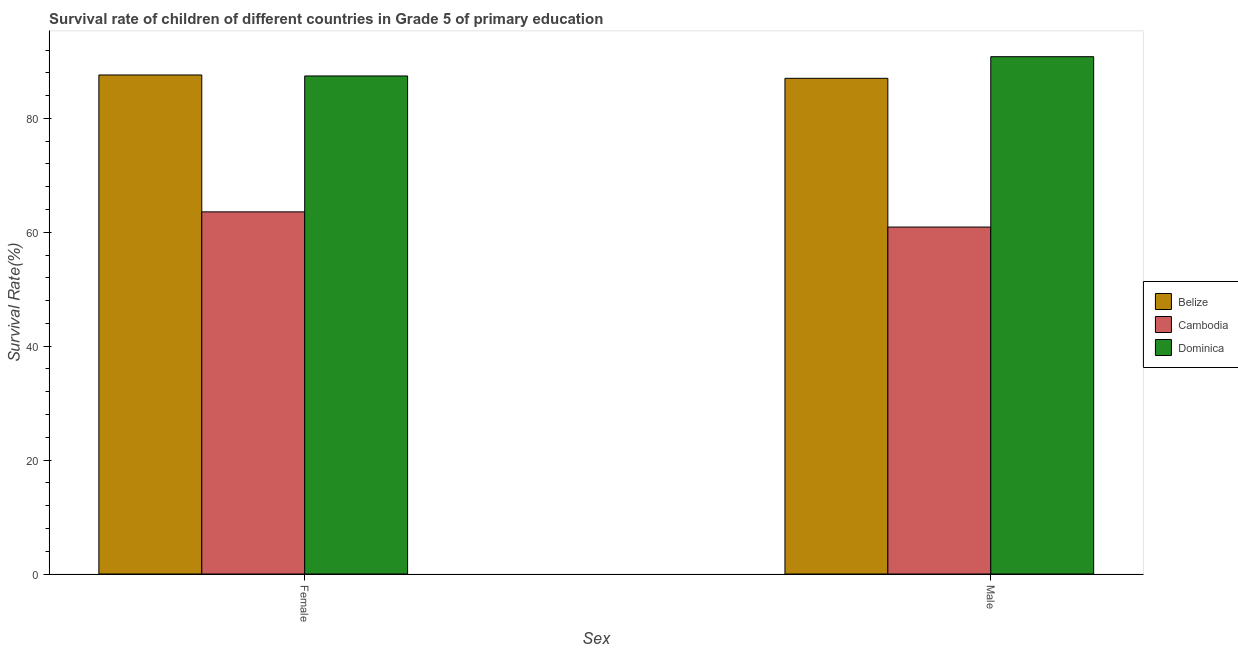Are the number of bars on each tick of the X-axis equal?
Provide a short and direct response. Yes. How many bars are there on the 2nd tick from the left?
Give a very brief answer. 3. How many bars are there on the 1st tick from the right?
Ensure brevity in your answer.  3. What is the label of the 2nd group of bars from the left?
Your answer should be very brief. Male. What is the survival rate of male students in primary education in Cambodia?
Give a very brief answer. 60.92. Across all countries, what is the maximum survival rate of female students in primary education?
Provide a succinct answer. 87.63. Across all countries, what is the minimum survival rate of male students in primary education?
Provide a succinct answer. 60.92. In which country was the survival rate of female students in primary education maximum?
Provide a short and direct response. Belize. In which country was the survival rate of female students in primary education minimum?
Keep it short and to the point. Cambodia. What is the total survival rate of female students in primary education in the graph?
Your response must be concise. 238.67. What is the difference between the survival rate of female students in primary education in Dominica and that in Cambodia?
Ensure brevity in your answer.  23.87. What is the difference between the survival rate of male students in primary education in Cambodia and the survival rate of female students in primary education in Dominica?
Ensure brevity in your answer.  -26.54. What is the average survival rate of female students in primary education per country?
Offer a terse response. 79.56. What is the difference between the survival rate of female students in primary education and survival rate of male students in primary education in Dominica?
Keep it short and to the point. -3.38. In how many countries, is the survival rate of male students in primary education greater than 52 %?
Your response must be concise. 3. What is the ratio of the survival rate of female students in primary education in Cambodia to that in Dominica?
Your answer should be compact. 0.73. Is the survival rate of female students in primary education in Dominica less than that in Cambodia?
Your answer should be compact. No. What does the 3rd bar from the left in Male represents?
Provide a succinct answer. Dominica. What does the 2nd bar from the right in Male represents?
Offer a terse response. Cambodia. How many bars are there?
Ensure brevity in your answer.  6. Are all the bars in the graph horizontal?
Provide a succinct answer. No. Where does the legend appear in the graph?
Ensure brevity in your answer.  Center right. How many legend labels are there?
Provide a succinct answer. 3. How are the legend labels stacked?
Offer a terse response. Vertical. What is the title of the graph?
Your answer should be very brief. Survival rate of children of different countries in Grade 5 of primary education. Does "Malta" appear as one of the legend labels in the graph?
Make the answer very short. No. What is the label or title of the X-axis?
Offer a very short reply. Sex. What is the label or title of the Y-axis?
Provide a succinct answer. Survival Rate(%). What is the Survival Rate(%) in Belize in Female?
Ensure brevity in your answer.  87.63. What is the Survival Rate(%) in Cambodia in Female?
Give a very brief answer. 63.59. What is the Survival Rate(%) in Dominica in Female?
Give a very brief answer. 87.46. What is the Survival Rate(%) of Belize in Male?
Keep it short and to the point. 87.04. What is the Survival Rate(%) in Cambodia in Male?
Keep it short and to the point. 60.92. What is the Survival Rate(%) in Dominica in Male?
Offer a very short reply. 90.84. Across all Sex, what is the maximum Survival Rate(%) of Belize?
Your response must be concise. 87.63. Across all Sex, what is the maximum Survival Rate(%) of Cambodia?
Make the answer very short. 63.59. Across all Sex, what is the maximum Survival Rate(%) of Dominica?
Make the answer very short. 90.84. Across all Sex, what is the minimum Survival Rate(%) of Belize?
Provide a succinct answer. 87.04. Across all Sex, what is the minimum Survival Rate(%) in Cambodia?
Provide a short and direct response. 60.92. Across all Sex, what is the minimum Survival Rate(%) of Dominica?
Offer a very short reply. 87.46. What is the total Survival Rate(%) of Belize in the graph?
Keep it short and to the point. 174.67. What is the total Survival Rate(%) in Cambodia in the graph?
Make the answer very short. 124.51. What is the total Survival Rate(%) in Dominica in the graph?
Your answer should be compact. 178.3. What is the difference between the Survival Rate(%) in Belize in Female and that in Male?
Provide a short and direct response. 0.59. What is the difference between the Survival Rate(%) in Cambodia in Female and that in Male?
Offer a very short reply. 2.67. What is the difference between the Survival Rate(%) in Dominica in Female and that in Male?
Your answer should be compact. -3.38. What is the difference between the Survival Rate(%) in Belize in Female and the Survival Rate(%) in Cambodia in Male?
Keep it short and to the point. 26.71. What is the difference between the Survival Rate(%) in Belize in Female and the Survival Rate(%) in Dominica in Male?
Offer a very short reply. -3.21. What is the difference between the Survival Rate(%) in Cambodia in Female and the Survival Rate(%) in Dominica in Male?
Offer a terse response. -27.25. What is the average Survival Rate(%) in Belize per Sex?
Provide a short and direct response. 87.34. What is the average Survival Rate(%) in Cambodia per Sex?
Make the answer very short. 62.25. What is the average Survival Rate(%) of Dominica per Sex?
Offer a terse response. 89.15. What is the difference between the Survival Rate(%) in Belize and Survival Rate(%) in Cambodia in Female?
Make the answer very short. 24.04. What is the difference between the Survival Rate(%) in Belize and Survival Rate(%) in Dominica in Female?
Your answer should be very brief. 0.17. What is the difference between the Survival Rate(%) in Cambodia and Survival Rate(%) in Dominica in Female?
Provide a succinct answer. -23.87. What is the difference between the Survival Rate(%) in Belize and Survival Rate(%) in Cambodia in Male?
Ensure brevity in your answer.  26.12. What is the difference between the Survival Rate(%) of Belize and Survival Rate(%) of Dominica in Male?
Offer a very short reply. -3.8. What is the difference between the Survival Rate(%) of Cambodia and Survival Rate(%) of Dominica in Male?
Your answer should be compact. -29.92. What is the ratio of the Survival Rate(%) of Belize in Female to that in Male?
Make the answer very short. 1.01. What is the ratio of the Survival Rate(%) in Cambodia in Female to that in Male?
Ensure brevity in your answer.  1.04. What is the ratio of the Survival Rate(%) in Dominica in Female to that in Male?
Offer a terse response. 0.96. What is the difference between the highest and the second highest Survival Rate(%) in Belize?
Your answer should be very brief. 0.59. What is the difference between the highest and the second highest Survival Rate(%) in Cambodia?
Make the answer very short. 2.67. What is the difference between the highest and the second highest Survival Rate(%) of Dominica?
Offer a very short reply. 3.38. What is the difference between the highest and the lowest Survival Rate(%) of Belize?
Your answer should be very brief. 0.59. What is the difference between the highest and the lowest Survival Rate(%) of Cambodia?
Keep it short and to the point. 2.67. What is the difference between the highest and the lowest Survival Rate(%) in Dominica?
Give a very brief answer. 3.38. 